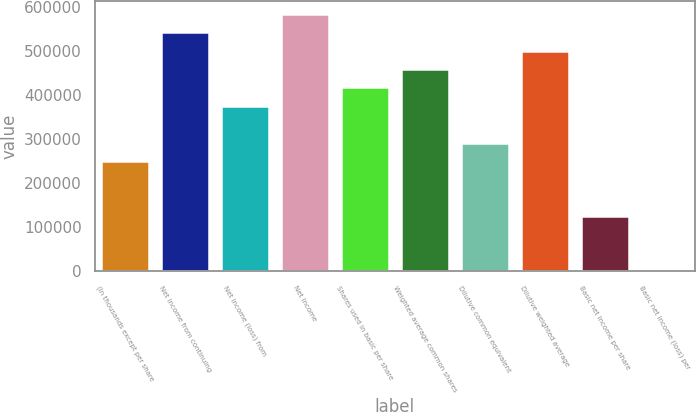Convert chart to OTSL. <chart><loc_0><loc_0><loc_500><loc_500><bar_chart><fcel>(In thousands except per share<fcel>Net income from continuing<fcel>Net income (loss) from<fcel>Net income<fcel>Shares used in basic per share<fcel>Weighted average common shares<fcel>Dilutive common equivalent<fcel>Dilutive weighted average<fcel>Basic net income per share<fcel>Basic net income (loss) per<nl><fcel>250178<fcel>542052<fcel>375267<fcel>583748<fcel>416963<fcel>458659<fcel>291874<fcel>500356<fcel>125089<fcel>0.11<nl></chart> 